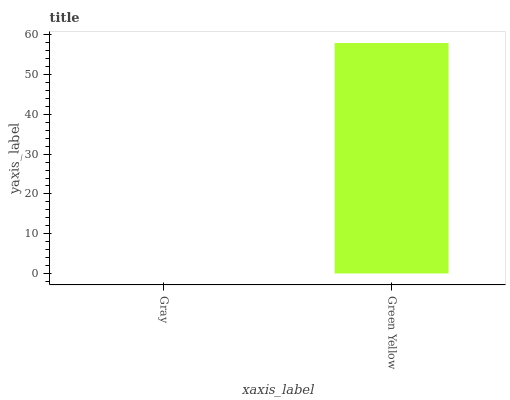Is Gray the minimum?
Answer yes or no. Yes. Is Green Yellow the maximum?
Answer yes or no. Yes. Is Green Yellow the minimum?
Answer yes or no. No. Is Green Yellow greater than Gray?
Answer yes or no. Yes. Is Gray less than Green Yellow?
Answer yes or no. Yes. Is Gray greater than Green Yellow?
Answer yes or no. No. Is Green Yellow less than Gray?
Answer yes or no. No. Is Green Yellow the high median?
Answer yes or no. Yes. Is Gray the low median?
Answer yes or no. Yes. Is Gray the high median?
Answer yes or no. No. Is Green Yellow the low median?
Answer yes or no. No. 